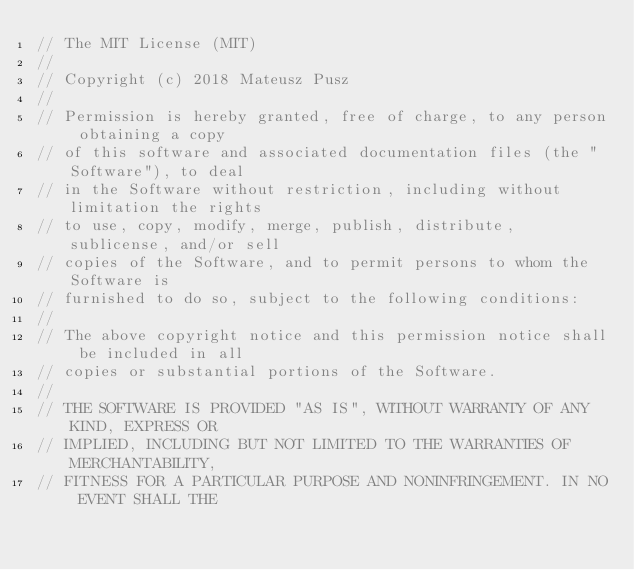Convert code to text. <code><loc_0><loc_0><loc_500><loc_500><_C_>// The MIT License (MIT)
//
// Copyright (c) 2018 Mateusz Pusz
//
// Permission is hereby granted, free of charge, to any person obtaining a copy
// of this software and associated documentation files (the "Software"), to deal
// in the Software without restriction, including without limitation the rights
// to use, copy, modify, merge, publish, distribute, sublicense, and/or sell
// copies of the Software, and to permit persons to whom the Software is
// furnished to do so, subject to the following conditions:
//
// The above copyright notice and this permission notice shall be included in all
// copies or substantial portions of the Software.
//
// THE SOFTWARE IS PROVIDED "AS IS", WITHOUT WARRANTY OF ANY KIND, EXPRESS OR
// IMPLIED, INCLUDING BUT NOT LIMITED TO THE WARRANTIES OF MERCHANTABILITY,
// FITNESS FOR A PARTICULAR PURPOSE AND NONINFRINGEMENT. IN NO EVENT SHALL THE</code> 